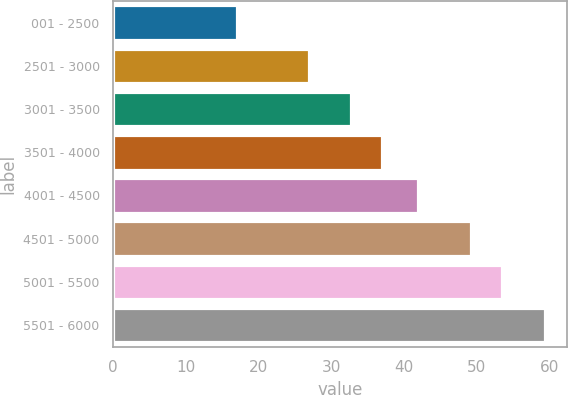<chart> <loc_0><loc_0><loc_500><loc_500><bar_chart><fcel>001 - 2500<fcel>2501 - 3000<fcel>3001 - 3500<fcel>3501 - 4000<fcel>4001 - 4500<fcel>4501 - 5000<fcel>5001 - 5500<fcel>5501 - 6000<nl><fcel>17.04<fcel>26.92<fcel>32.73<fcel>36.97<fcel>41.88<fcel>49.15<fcel>53.39<fcel>59.42<nl></chart> 